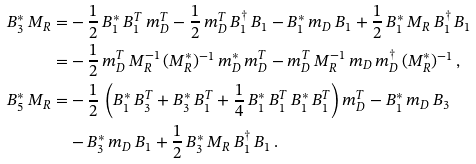Convert formula to latex. <formula><loc_0><loc_0><loc_500><loc_500>B _ { 3 } ^ { \ast } \, M _ { R } = & - \frac { 1 } { 2 } \, B _ { 1 } ^ { \ast } \, B _ { 1 } ^ { T } \, m _ { D } ^ { T } - \frac { 1 } { 2 } \, m _ { D } ^ { T } \, B _ { 1 } ^ { \dagger } \, B _ { 1 } - B _ { 1 } ^ { \ast } \, m _ { D } \, B _ { 1 } + \frac { 1 } { 2 } \, B _ { 1 } ^ { \ast } \, M _ { R } \, B _ { 1 } ^ { \dagger } \, B _ { 1 } \\ = & - \frac { 1 } { 2 } \, m _ { D } ^ { T } \, M _ { R } ^ { - 1 } \, ( M _ { R } ^ { \ast } ) ^ { - 1 } \, m _ { D } ^ { \ast } \, m _ { D } ^ { T } - m _ { D } ^ { T } \, M _ { R } ^ { - 1 } \, m _ { D } \, m _ { D } ^ { \dagger } \, ( M _ { R } ^ { \ast } ) ^ { - 1 } \, , \\ B _ { 5 } ^ { \ast } \, M _ { R } = & - \frac { 1 } { 2 } \, \left ( B _ { 1 } ^ { \ast } \, B _ { 3 } ^ { T } + B _ { 3 } ^ { \ast } \, B _ { 1 } ^ { T } + \frac { 1 } { 4 } \, B _ { 1 } ^ { \ast } \, B _ { 1 } ^ { T } \, B _ { 1 } ^ { \ast } \, B _ { 1 } ^ { T } \right ) m _ { D } ^ { T } - B _ { 1 } ^ { \ast } \, m _ { D } \, B _ { 3 } \\ & - B _ { 3 } ^ { \ast } \, m _ { D } \, B _ { 1 } + \frac { 1 } { 2 } \, B _ { 3 } ^ { \ast } \, M _ { R } \, B _ { 1 } ^ { \dagger } \, B _ { 1 } \, .</formula> 